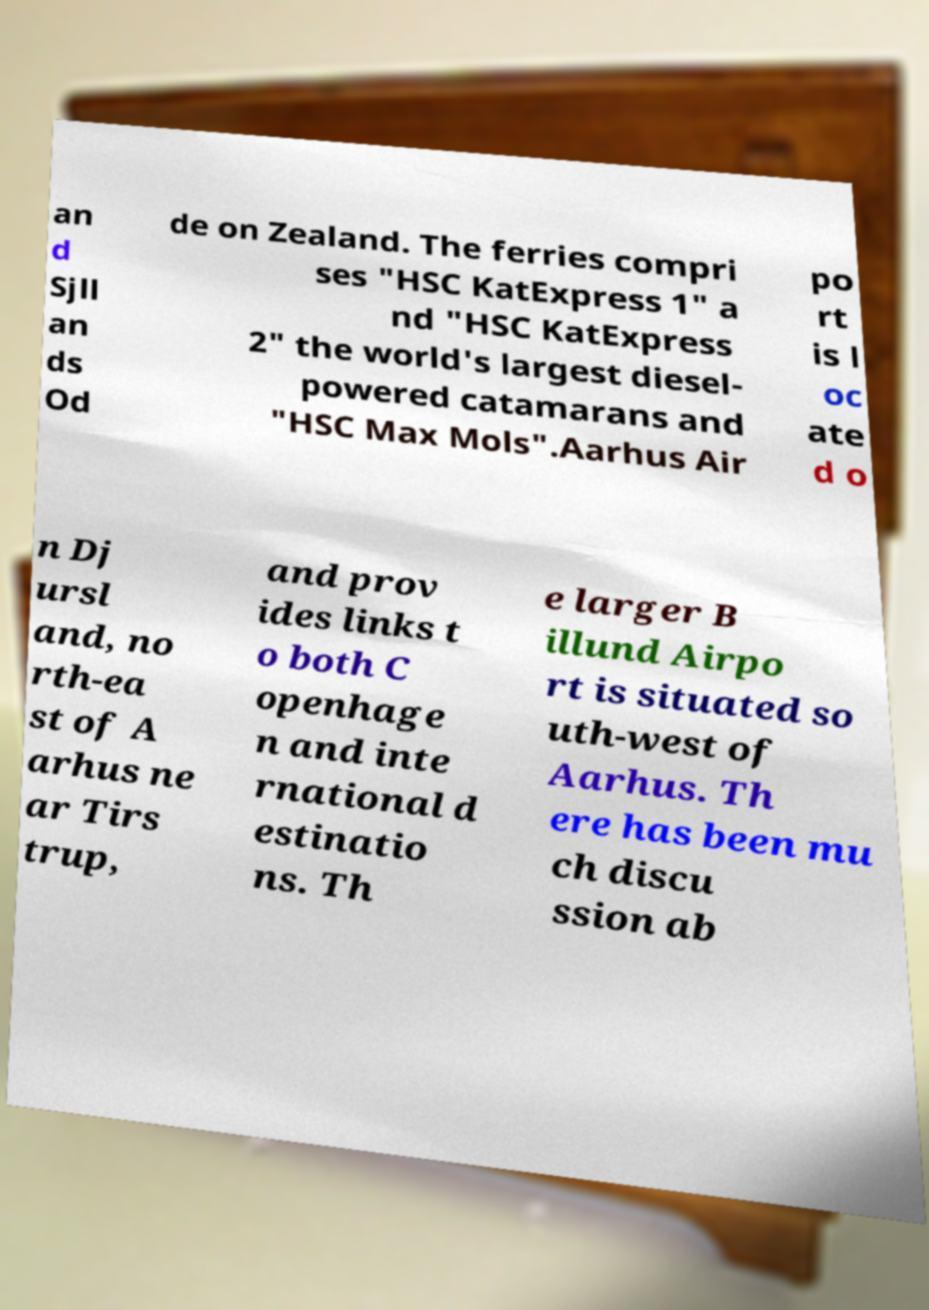Could you assist in decoding the text presented in this image and type it out clearly? an d Sjll an ds Od de on Zealand. The ferries compri ses "HSC KatExpress 1" a nd "HSC KatExpress 2" the world's largest diesel- powered catamarans and "HSC Max Mols".Aarhus Air po rt is l oc ate d o n Dj ursl and, no rth-ea st of A arhus ne ar Tirs trup, and prov ides links t o both C openhage n and inte rnational d estinatio ns. Th e larger B illund Airpo rt is situated so uth-west of Aarhus. Th ere has been mu ch discu ssion ab 